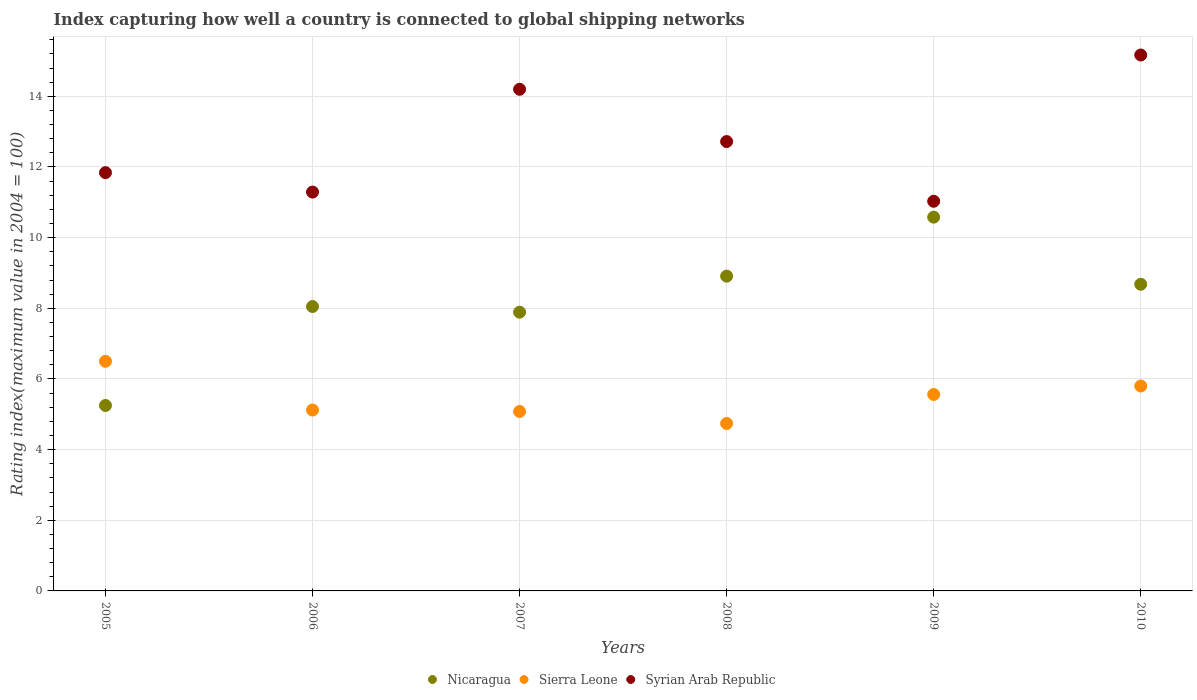What is the rating index in Nicaragua in 2006?
Offer a terse response. 8.05. Across all years, what is the minimum rating index in Sierra Leone?
Offer a terse response. 4.74. In which year was the rating index in Nicaragua maximum?
Your answer should be compact. 2009. What is the total rating index in Nicaragua in the graph?
Make the answer very short. 49.36. What is the difference between the rating index in Nicaragua in 2005 and that in 2009?
Offer a very short reply. -5.33. What is the difference between the rating index in Sierra Leone in 2005 and the rating index in Nicaragua in 2008?
Provide a succinct answer. -2.41. What is the average rating index in Syrian Arab Republic per year?
Your response must be concise. 12.71. In the year 2005, what is the difference between the rating index in Syrian Arab Republic and rating index in Sierra Leone?
Your answer should be compact. 5.34. In how many years, is the rating index in Sierra Leone greater than 9.2?
Give a very brief answer. 0. What is the ratio of the rating index in Nicaragua in 2007 to that in 2009?
Your answer should be very brief. 0.75. Is the difference between the rating index in Syrian Arab Republic in 2007 and 2009 greater than the difference between the rating index in Sierra Leone in 2007 and 2009?
Give a very brief answer. Yes. What is the difference between the highest and the second highest rating index in Nicaragua?
Keep it short and to the point. 1.67. What is the difference between the highest and the lowest rating index in Syrian Arab Republic?
Give a very brief answer. 4.14. In how many years, is the rating index in Nicaragua greater than the average rating index in Nicaragua taken over all years?
Give a very brief answer. 3. Is the sum of the rating index in Nicaragua in 2006 and 2007 greater than the maximum rating index in Sierra Leone across all years?
Provide a short and direct response. Yes. Does the rating index in Nicaragua monotonically increase over the years?
Provide a short and direct response. No. Is the rating index in Nicaragua strictly less than the rating index in Sierra Leone over the years?
Provide a succinct answer. No. How many dotlines are there?
Ensure brevity in your answer.  3. What is the difference between two consecutive major ticks on the Y-axis?
Offer a very short reply. 2. Does the graph contain any zero values?
Make the answer very short. No. Does the graph contain grids?
Your answer should be very brief. Yes. Where does the legend appear in the graph?
Make the answer very short. Bottom center. How many legend labels are there?
Provide a short and direct response. 3. How are the legend labels stacked?
Your response must be concise. Horizontal. What is the title of the graph?
Your answer should be compact. Index capturing how well a country is connected to global shipping networks. Does "Solomon Islands" appear as one of the legend labels in the graph?
Provide a short and direct response. No. What is the label or title of the X-axis?
Make the answer very short. Years. What is the label or title of the Y-axis?
Provide a succinct answer. Rating index(maximum value in 2004 = 100). What is the Rating index(maximum value in 2004 = 100) in Nicaragua in 2005?
Your answer should be compact. 5.25. What is the Rating index(maximum value in 2004 = 100) in Syrian Arab Republic in 2005?
Offer a terse response. 11.84. What is the Rating index(maximum value in 2004 = 100) of Nicaragua in 2006?
Give a very brief answer. 8.05. What is the Rating index(maximum value in 2004 = 100) of Sierra Leone in 2006?
Make the answer very short. 5.12. What is the Rating index(maximum value in 2004 = 100) in Syrian Arab Republic in 2006?
Make the answer very short. 11.29. What is the Rating index(maximum value in 2004 = 100) in Nicaragua in 2007?
Your response must be concise. 7.89. What is the Rating index(maximum value in 2004 = 100) in Sierra Leone in 2007?
Ensure brevity in your answer.  5.08. What is the Rating index(maximum value in 2004 = 100) in Syrian Arab Republic in 2007?
Make the answer very short. 14.2. What is the Rating index(maximum value in 2004 = 100) of Nicaragua in 2008?
Provide a succinct answer. 8.91. What is the Rating index(maximum value in 2004 = 100) of Sierra Leone in 2008?
Give a very brief answer. 4.74. What is the Rating index(maximum value in 2004 = 100) of Syrian Arab Republic in 2008?
Keep it short and to the point. 12.72. What is the Rating index(maximum value in 2004 = 100) of Nicaragua in 2009?
Give a very brief answer. 10.58. What is the Rating index(maximum value in 2004 = 100) in Sierra Leone in 2009?
Give a very brief answer. 5.56. What is the Rating index(maximum value in 2004 = 100) of Syrian Arab Republic in 2009?
Give a very brief answer. 11.03. What is the Rating index(maximum value in 2004 = 100) in Nicaragua in 2010?
Provide a short and direct response. 8.68. What is the Rating index(maximum value in 2004 = 100) in Sierra Leone in 2010?
Offer a very short reply. 5.8. What is the Rating index(maximum value in 2004 = 100) of Syrian Arab Republic in 2010?
Your answer should be compact. 15.17. Across all years, what is the maximum Rating index(maximum value in 2004 = 100) of Nicaragua?
Provide a succinct answer. 10.58. Across all years, what is the maximum Rating index(maximum value in 2004 = 100) in Sierra Leone?
Make the answer very short. 6.5. Across all years, what is the maximum Rating index(maximum value in 2004 = 100) in Syrian Arab Republic?
Your response must be concise. 15.17. Across all years, what is the minimum Rating index(maximum value in 2004 = 100) in Nicaragua?
Provide a short and direct response. 5.25. Across all years, what is the minimum Rating index(maximum value in 2004 = 100) in Sierra Leone?
Your answer should be compact. 4.74. Across all years, what is the minimum Rating index(maximum value in 2004 = 100) of Syrian Arab Republic?
Provide a short and direct response. 11.03. What is the total Rating index(maximum value in 2004 = 100) in Nicaragua in the graph?
Make the answer very short. 49.36. What is the total Rating index(maximum value in 2004 = 100) in Sierra Leone in the graph?
Offer a very short reply. 32.8. What is the total Rating index(maximum value in 2004 = 100) of Syrian Arab Republic in the graph?
Offer a very short reply. 76.25. What is the difference between the Rating index(maximum value in 2004 = 100) in Nicaragua in 2005 and that in 2006?
Ensure brevity in your answer.  -2.8. What is the difference between the Rating index(maximum value in 2004 = 100) of Sierra Leone in 2005 and that in 2006?
Provide a short and direct response. 1.38. What is the difference between the Rating index(maximum value in 2004 = 100) in Syrian Arab Republic in 2005 and that in 2006?
Give a very brief answer. 0.55. What is the difference between the Rating index(maximum value in 2004 = 100) in Nicaragua in 2005 and that in 2007?
Your answer should be compact. -2.64. What is the difference between the Rating index(maximum value in 2004 = 100) in Sierra Leone in 2005 and that in 2007?
Your answer should be compact. 1.42. What is the difference between the Rating index(maximum value in 2004 = 100) of Syrian Arab Republic in 2005 and that in 2007?
Make the answer very short. -2.36. What is the difference between the Rating index(maximum value in 2004 = 100) of Nicaragua in 2005 and that in 2008?
Your answer should be very brief. -3.66. What is the difference between the Rating index(maximum value in 2004 = 100) in Sierra Leone in 2005 and that in 2008?
Offer a terse response. 1.76. What is the difference between the Rating index(maximum value in 2004 = 100) of Syrian Arab Republic in 2005 and that in 2008?
Your response must be concise. -0.88. What is the difference between the Rating index(maximum value in 2004 = 100) in Nicaragua in 2005 and that in 2009?
Offer a terse response. -5.33. What is the difference between the Rating index(maximum value in 2004 = 100) in Sierra Leone in 2005 and that in 2009?
Your answer should be compact. 0.94. What is the difference between the Rating index(maximum value in 2004 = 100) in Syrian Arab Republic in 2005 and that in 2009?
Ensure brevity in your answer.  0.81. What is the difference between the Rating index(maximum value in 2004 = 100) of Nicaragua in 2005 and that in 2010?
Your answer should be very brief. -3.43. What is the difference between the Rating index(maximum value in 2004 = 100) in Sierra Leone in 2005 and that in 2010?
Offer a very short reply. 0.7. What is the difference between the Rating index(maximum value in 2004 = 100) of Syrian Arab Republic in 2005 and that in 2010?
Your answer should be compact. -3.33. What is the difference between the Rating index(maximum value in 2004 = 100) of Nicaragua in 2006 and that in 2007?
Provide a short and direct response. 0.16. What is the difference between the Rating index(maximum value in 2004 = 100) of Sierra Leone in 2006 and that in 2007?
Provide a succinct answer. 0.04. What is the difference between the Rating index(maximum value in 2004 = 100) of Syrian Arab Republic in 2006 and that in 2007?
Ensure brevity in your answer.  -2.91. What is the difference between the Rating index(maximum value in 2004 = 100) in Nicaragua in 2006 and that in 2008?
Make the answer very short. -0.86. What is the difference between the Rating index(maximum value in 2004 = 100) in Sierra Leone in 2006 and that in 2008?
Give a very brief answer. 0.38. What is the difference between the Rating index(maximum value in 2004 = 100) in Syrian Arab Republic in 2006 and that in 2008?
Your answer should be compact. -1.43. What is the difference between the Rating index(maximum value in 2004 = 100) of Nicaragua in 2006 and that in 2009?
Give a very brief answer. -2.53. What is the difference between the Rating index(maximum value in 2004 = 100) in Sierra Leone in 2006 and that in 2009?
Keep it short and to the point. -0.44. What is the difference between the Rating index(maximum value in 2004 = 100) in Syrian Arab Republic in 2006 and that in 2009?
Offer a terse response. 0.26. What is the difference between the Rating index(maximum value in 2004 = 100) of Nicaragua in 2006 and that in 2010?
Your answer should be very brief. -0.63. What is the difference between the Rating index(maximum value in 2004 = 100) of Sierra Leone in 2006 and that in 2010?
Your response must be concise. -0.68. What is the difference between the Rating index(maximum value in 2004 = 100) in Syrian Arab Republic in 2006 and that in 2010?
Make the answer very short. -3.88. What is the difference between the Rating index(maximum value in 2004 = 100) of Nicaragua in 2007 and that in 2008?
Keep it short and to the point. -1.02. What is the difference between the Rating index(maximum value in 2004 = 100) of Sierra Leone in 2007 and that in 2008?
Ensure brevity in your answer.  0.34. What is the difference between the Rating index(maximum value in 2004 = 100) of Syrian Arab Republic in 2007 and that in 2008?
Provide a short and direct response. 1.48. What is the difference between the Rating index(maximum value in 2004 = 100) in Nicaragua in 2007 and that in 2009?
Provide a short and direct response. -2.69. What is the difference between the Rating index(maximum value in 2004 = 100) in Sierra Leone in 2007 and that in 2009?
Make the answer very short. -0.48. What is the difference between the Rating index(maximum value in 2004 = 100) in Syrian Arab Republic in 2007 and that in 2009?
Provide a short and direct response. 3.17. What is the difference between the Rating index(maximum value in 2004 = 100) of Nicaragua in 2007 and that in 2010?
Provide a short and direct response. -0.79. What is the difference between the Rating index(maximum value in 2004 = 100) in Sierra Leone in 2007 and that in 2010?
Offer a terse response. -0.72. What is the difference between the Rating index(maximum value in 2004 = 100) in Syrian Arab Republic in 2007 and that in 2010?
Make the answer very short. -0.97. What is the difference between the Rating index(maximum value in 2004 = 100) in Nicaragua in 2008 and that in 2009?
Your answer should be very brief. -1.67. What is the difference between the Rating index(maximum value in 2004 = 100) in Sierra Leone in 2008 and that in 2009?
Make the answer very short. -0.82. What is the difference between the Rating index(maximum value in 2004 = 100) of Syrian Arab Republic in 2008 and that in 2009?
Make the answer very short. 1.69. What is the difference between the Rating index(maximum value in 2004 = 100) in Nicaragua in 2008 and that in 2010?
Ensure brevity in your answer.  0.23. What is the difference between the Rating index(maximum value in 2004 = 100) in Sierra Leone in 2008 and that in 2010?
Your answer should be very brief. -1.06. What is the difference between the Rating index(maximum value in 2004 = 100) of Syrian Arab Republic in 2008 and that in 2010?
Your response must be concise. -2.45. What is the difference between the Rating index(maximum value in 2004 = 100) in Nicaragua in 2009 and that in 2010?
Ensure brevity in your answer.  1.9. What is the difference between the Rating index(maximum value in 2004 = 100) in Sierra Leone in 2009 and that in 2010?
Provide a succinct answer. -0.24. What is the difference between the Rating index(maximum value in 2004 = 100) in Syrian Arab Republic in 2009 and that in 2010?
Offer a very short reply. -4.14. What is the difference between the Rating index(maximum value in 2004 = 100) of Nicaragua in 2005 and the Rating index(maximum value in 2004 = 100) of Sierra Leone in 2006?
Make the answer very short. 0.13. What is the difference between the Rating index(maximum value in 2004 = 100) of Nicaragua in 2005 and the Rating index(maximum value in 2004 = 100) of Syrian Arab Republic in 2006?
Keep it short and to the point. -6.04. What is the difference between the Rating index(maximum value in 2004 = 100) of Sierra Leone in 2005 and the Rating index(maximum value in 2004 = 100) of Syrian Arab Republic in 2006?
Your answer should be very brief. -4.79. What is the difference between the Rating index(maximum value in 2004 = 100) of Nicaragua in 2005 and the Rating index(maximum value in 2004 = 100) of Sierra Leone in 2007?
Offer a terse response. 0.17. What is the difference between the Rating index(maximum value in 2004 = 100) of Nicaragua in 2005 and the Rating index(maximum value in 2004 = 100) of Syrian Arab Republic in 2007?
Provide a succinct answer. -8.95. What is the difference between the Rating index(maximum value in 2004 = 100) of Sierra Leone in 2005 and the Rating index(maximum value in 2004 = 100) of Syrian Arab Republic in 2007?
Give a very brief answer. -7.7. What is the difference between the Rating index(maximum value in 2004 = 100) in Nicaragua in 2005 and the Rating index(maximum value in 2004 = 100) in Sierra Leone in 2008?
Your answer should be very brief. 0.51. What is the difference between the Rating index(maximum value in 2004 = 100) of Nicaragua in 2005 and the Rating index(maximum value in 2004 = 100) of Syrian Arab Republic in 2008?
Ensure brevity in your answer.  -7.47. What is the difference between the Rating index(maximum value in 2004 = 100) of Sierra Leone in 2005 and the Rating index(maximum value in 2004 = 100) of Syrian Arab Republic in 2008?
Provide a succinct answer. -6.22. What is the difference between the Rating index(maximum value in 2004 = 100) of Nicaragua in 2005 and the Rating index(maximum value in 2004 = 100) of Sierra Leone in 2009?
Give a very brief answer. -0.31. What is the difference between the Rating index(maximum value in 2004 = 100) in Nicaragua in 2005 and the Rating index(maximum value in 2004 = 100) in Syrian Arab Republic in 2009?
Keep it short and to the point. -5.78. What is the difference between the Rating index(maximum value in 2004 = 100) of Sierra Leone in 2005 and the Rating index(maximum value in 2004 = 100) of Syrian Arab Republic in 2009?
Your answer should be compact. -4.53. What is the difference between the Rating index(maximum value in 2004 = 100) in Nicaragua in 2005 and the Rating index(maximum value in 2004 = 100) in Sierra Leone in 2010?
Provide a succinct answer. -0.55. What is the difference between the Rating index(maximum value in 2004 = 100) in Nicaragua in 2005 and the Rating index(maximum value in 2004 = 100) in Syrian Arab Republic in 2010?
Make the answer very short. -9.92. What is the difference between the Rating index(maximum value in 2004 = 100) of Sierra Leone in 2005 and the Rating index(maximum value in 2004 = 100) of Syrian Arab Republic in 2010?
Ensure brevity in your answer.  -8.67. What is the difference between the Rating index(maximum value in 2004 = 100) of Nicaragua in 2006 and the Rating index(maximum value in 2004 = 100) of Sierra Leone in 2007?
Give a very brief answer. 2.97. What is the difference between the Rating index(maximum value in 2004 = 100) in Nicaragua in 2006 and the Rating index(maximum value in 2004 = 100) in Syrian Arab Republic in 2007?
Your answer should be very brief. -6.15. What is the difference between the Rating index(maximum value in 2004 = 100) of Sierra Leone in 2006 and the Rating index(maximum value in 2004 = 100) of Syrian Arab Republic in 2007?
Offer a terse response. -9.08. What is the difference between the Rating index(maximum value in 2004 = 100) in Nicaragua in 2006 and the Rating index(maximum value in 2004 = 100) in Sierra Leone in 2008?
Ensure brevity in your answer.  3.31. What is the difference between the Rating index(maximum value in 2004 = 100) in Nicaragua in 2006 and the Rating index(maximum value in 2004 = 100) in Syrian Arab Republic in 2008?
Ensure brevity in your answer.  -4.67. What is the difference between the Rating index(maximum value in 2004 = 100) of Sierra Leone in 2006 and the Rating index(maximum value in 2004 = 100) of Syrian Arab Republic in 2008?
Ensure brevity in your answer.  -7.6. What is the difference between the Rating index(maximum value in 2004 = 100) in Nicaragua in 2006 and the Rating index(maximum value in 2004 = 100) in Sierra Leone in 2009?
Provide a short and direct response. 2.49. What is the difference between the Rating index(maximum value in 2004 = 100) of Nicaragua in 2006 and the Rating index(maximum value in 2004 = 100) of Syrian Arab Republic in 2009?
Provide a succinct answer. -2.98. What is the difference between the Rating index(maximum value in 2004 = 100) of Sierra Leone in 2006 and the Rating index(maximum value in 2004 = 100) of Syrian Arab Republic in 2009?
Give a very brief answer. -5.91. What is the difference between the Rating index(maximum value in 2004 = 100) in Nicaragua in 2006 and the Rating index(maximum value in 2004 = 100) in Sierra Leone in 2010?
Ensure brevity in your answer.  2.25. What is the difference between the Rating index(maximum value in 2004 = 100) in Nicaragua in 2006 and the Rating index(maximum value in 2004 = 100) in Syrian Arab Republic in 2010?
Provide a short and direct response. -7.12. What is the difference between the Rating index(maximum value in 2004 = 100) in Sierra Leone in 2006 and the Rating index(maximum value in 2004 = 100) in Syrian Arab Republic in 2010?
Ensure brevity in your answer.  -10.05. What is the difference between the Rating index(maximum value in 2004 = 100) of Nicaragua in 2007 and the Rating index(maximum value in 2004 = 100) of Sierra Leone in 2008?
Make the answer very short. 3.15. What is the difference between the Rating index(maximum value in 2004 = 100) of Nicaragua in 2007 and the Rating index(maximum value in 2004 = 100) of Syrian Arab Republic in 2008?
Make the answer very short. -4.83. What is the difference between the Rating index(maximum value in 2004 = 100) of Sierra Leone in 2007 and the Rating index(maximum value in 2004 = 100) of Syrian Arab Republic in 2008?
Provide a short and direct response. -7.64. What is the difference between the Rating index(maximum value in 2004 = 100) in Nicaragua in 2007 and the Rating index(maximum value in 2004 = 100) in Sierra Leone in 2009?
Provide a short and direct response. 2.33. What is the difference between the Rating index(maximum value in 2004 = 100) in Nicaragua in 2007 and the Rating index(maximum value in 2004 = 100) in Syrian Arab Republic in 2009?
Your answer should be very brief. -3.14. What is the difference between the Rating index(maximum value in 2004 = 100) in Sierra Leone in 2007 and the Rating index(maximum value in 2004 = 100) in Syrian Arab Republic in 2009?
Offer a terse response. -5.95. What is the difference between the Rating index(maximum value in 2004 = 100) of Nicaragua in 2007 and the Rating index(maximum value in 2004 = 100) of Sierra Leone in 2010?
Offer a very short reply. 2.09. What is the difference between the Rating index(maximum value in 2004 = 100) of Nicaragua in 2007 and the Rating index(maximum value in 2004 = 100) of Syrian Arab Republic in 2010?
Offer a terse response. -7.28. What is the difference between the Rating index(maximum value in 2004 = 100) of Sierra Leone in 2007 and the Rating index(maximum value in 2004 = 100) of Syrian Arab Republic in 2010?
Offer a very short reply. -10.09. What is the difference between the Rating index(maximum value in 2004 = 100) in Nicaragua in 2008 and the Rating index(maximum value in 2004 = 100) in Sierra Leone in 2009?
Offer a terse response. 3.35. What is the difference between the Rating index(maximum value in 2004 = 100) in Nicaragua in 2008 and the Rating index(maximum value in 2004 = 100) in Syrian Arab Republic in 2009?
Your answer should be very brief. -2.12. What is the difference between the Rating index(maximum value in 2004 = 100) of Sierra Leone in 2008 and the Rating index(maximum value in 2004 = 100) of Syrian Arab Republic in 2009?
Your response must be concise. -6.29. What is the difference between the Rating index(maximum value in 2004 = 100) in Nicaragua in 2008 and the Rating index(maximum value in 2004 = 100) in Sierra Leone in 2010?
Make the answer very short. 3.11. What is the difference between the Rating index(maximum value in 2004 = 100) of Nicaragua in 2008 and the Rating index(maximum value in 2004 = 100) of Syrian Arab Republic in 2010?
Offer a terse response. -6.26. What is the difference between the Rating index(maximum value in 2004 = 100) in Sierra Leone in 2008 and the Rating index(maximum value in 2004 = 100) in Syrian Arab Republic in 2010?
Your answer should be very brief. -10.43. What is the difference between the Rating index(maximum value in 2004 = 100) of Nicaragua in 2009 and the Rating index(maximum value in 2004 = 100) of Sierra Leone in 2010?
Provide a short and direct response. 4.78. What is the difference between the Rating index(maximum value in 2004 = 100) in Nicaragua in 2009 and the Rating index(maximum value in 2004 = 100) in Syrian Arab Republic in 2010?
Ensure brevity in your answer.  -4.59. What is the difference between the Rating index(maximum value in 2004 = 100) of Sierra Leone in 2009 and the Rating index(maximum value in 2004 = 100) of Syrian Arab Republic in 2010?
Offer a very short reply. -9.61. What is the average Rating index(maximum value in 2004 = 100) in Nicaragua per year?
Make the answer very short. 8.23. What is the average Rating index(maximum value in 2004 = 100) of Sierra Leone per year?
Your answer should be compact. 5.47. What is the average Rating index(maximum value in 2004 = 100) in Syrian Arab Republic per year?
Make the answer very short. 12.71. In the year 2005, what is the difference between the Rating index(maximum value in 2004 = 100) of Nicaragua and Rating index(maximum value in 2004 = 100) of Sierra Leone?
Keep it short and to the point. -1.25. In the year 2005, what is the difference between the Rating index(maximum value in 2004 = 100) in Nicaragua and Rating index(maximum value in 2004 = 100) in Syrian Arab Republic?
Ensure brevity in your answer.  -6.59. In the year 2005, what is the difference between the Rating index(maximum value in 2004 = 100) in Sierra Leone and Rating index(maximum value in 2004 = 100) in Syrian Arab Republic?
Ensure brevity in your answer.  -5.34. In the year 2006, what is the difference between the Rating index(maximum value in 2004 = 100) of Nicaragua and Rating index(maximum value in 2004 = 100) of Sierra Leone?
Your answer should be compact. 2.93. In the year 2006, what is the difference between the Rating index(maximum value in 2004 = 100) of Nicaragua and Rating index(maximum value in 2004 = 100) of Syrian Arab Republic?
Your answer should be very brief. -3.24. In the year 2006, what is the difference between the Rating index(maximum value in 2004 = 100) in Sierra Leone and Rating index(maximum value in 2004 = 100) in Syrian Arab Republic?
Your answer should be very brief. -6.17. In the year 2007, what is the difference between the Rating index(maximum value in 2004 = 100) in Nicaragua and Rating index(maximum value in 2004 = 100) in Sierra Leone?
Provide a succinct answer. 2.81. In the year 2007, what is the difference between the Rating index(maximum value in 2004 = 100) in Nicaragua and Rating index(maximum value in 2004 = 100) in Syrian Arab Republic?
Your response must be concise. -6.31. In the year 2007, what is the difference between the Rating index(maximum value in 2004 = 100) in Sierra Leone and Rating index(maximum value in 2004 = 100) in Syrian Arab Republic?
Your answer should be compact. -9.12. In the year 2008, what is the difference between the Rating index(maximum value in 2004 = 100) in Nicaragua and Rating index(maximum value in 2004 = 100) in Sierra Leone?
Provide a short and direct response. 4.17. In the year 2008, what is the difference between the Rating index(maximum value in 2004 = 100) of Nicaragua and Rating index(maximum value in 2004 = 100) of Syrian Arab Republic?
Keep it short and to the point. -3.81. In the year 2008, what is the difference between the Rating index(maximum value in 2004 = 100) of Sierra Leone and Rating index(maximum value in 2004 = 100) of Syrian Arab Republic?
Offer a very short reply. -7.98. In the year 2009, what is the difference between the Rating index(maximum value in 2004 = 100) in Nicaragua and Rating index(maximum value in 2004 = 100) in Sierra Leone?
Your answer should be very brief. 5.02. In the year 2009, what is the difference between the Rating index(maximum value in 2004 = 100) in Nicaragua and Rating index(maximum value in 2004 = 100) in Syrian Arab Republic?
Offer a very short reply. -0.45. In the year 2009, what is the difference between the Rating index(maximum value in 2004 = 100) in Sierra Leone and Rating index(maximum value in 2004 = 100) in Syrian Arab Republic?
Your response must be concise. -5.47. In the year 2010, what is the difference between the Rating index(maximum value in 2004 = 100) of Nicaragua and Rating index(maximum value in 2004 = 100) of Sierra Leone?
Make the answer very short. 2.88. In the year 2010, what is the difference between the Rating index(maximum value in 2004 = 100) of Nicaragua and Rating index(maximum value in 2004 = 100) of Syrian Arab Republic?
Keep it short and to the point. -6.49. In the year 2010, what is the difference between the Rating index(maximum value in 2004 = 100) of Sierra Leone and Rating index(maximum value in 2004 = 100) of Syrian Arab Republic?
Your answer should be very brief. -9.37. What is the ratio of the Rating index(maximum value in 2004 = 100) in Nicaragua in 2005 to that in 2006?
Provide a succinct answer. 0.65. What is the ratio of the Rating index(maximum value in 2004 = 100) of Sierra Leone in 2005 to that in 2006?
Ensure brevity in your answer.  1.27. What is the ratio of the Rating index(maximum value in 2004 = 100) of Syrian Arab Republic in 2005 to that in 2006?
Provide a succinct answer. 1.05. What is the ratio of the Rating index(maximum value in 2004 = 100) of Nicaragua in 2005 to that in 2007?
Offer a terse response. 0.67. What is the ratio of the Rating index(maximum value in 2004 = 100) in Sierra Leone in 2005 to that in 2007?
Provide a short and direct response. 1.28. What is the ratio of the Rating index(maximum value in 2004 = 100) of Syrian Arab Republic in 2005 to that in 2007?
Provide a short and direct response. 0.83. What is the ratio of the Rating index(maximum value in 2004 = 100) of Nicaragua in 2005 to that in 2008?
Make the answer very short. 0.59. What is the ratio of the Rating index(maximum value in 2004 = 100) of Sierra Leone in 2005 to that in 2008?
Offer a very short reply. 1.37. What is the ratio of the Rating index(maximum value in 2004 = 100) of Syrian Arab Republic in 2005 to that in 2008?
Offer a terse response. 0.93. What is the ratio of the Rating index(maximum value in 2004 = 100) in Nicaragua in 2005 to that in 2009?
Offer a very short reply. 0.5. What is the ratio of the Rating index(maximum value in 2004 = 100) of Sierra Leone in 2005 to that in 2009?
Offer a terse response. 1.17. What is the ratio of the Rating index(maximum value in 2004 = 100) of Syrian Arab Republic in 2005 to that in 2009?
Your answer should be compact. 1.07. What is the ratio of the Rating index(maximum value in 2004 = 100) in Nicaragua in 2005 to that in 2010?
Give a very brief answer. 0.6. What is the ratio of the Rating index(maximum value in 2004 = 100) of Sierra Leone in 2005 to that in 2010?
Provide a succinct answer. 1.12. What is the ratio of the Rating index(maximum value in 2004 = 100) of Syrian Arab Republic in 2005 to that in 2010?
Offer a very short reply. 0.78. What is the ratio of the Rating index(maximum value in 2004 = 100) in Nicaragua in 2006 to that in 2007?
Give a very brief answer. 1.02. What is the ratio of the Rating index(maximum value in 2004 = 100) of Sierra Leone in 2006 to that in 2007?
Offer a very short reply. 1.01. What is the ratio of the Rating index(maximum value in 2004 = 100) in Syrian Arab Republic in 2006 to that in 2007?
Your answer should be compact. 0.8. What is the ratio of the Rating index(maximum value in 2004 = 100) of Nicaragua in 2006 to that in 2008?
Make the answer very short. 0.9. What is the ratio of the Rating index(maximum value in 2004 = 100) of Sierra Leone in 2006 to that in 2008?
Give a very brief answer. 1.08. What is the ratio of the Rating index(maximum value in 2004 = 100) in Syrian Arab Republic in 2006 to that in 2008?
Give a very brief answer. 0.89. What is the ratio of the Rating index(maximum value in 2004 = 100) in Nicaragua in 2006 to that in 2009?
Make the answer very short. 0.76. What is the ratio of the Rating index(maximum value in 2004 = 100) in Sierra Leone in 2006 to that in 2009?
Give a very brief answer. 0.92. What is the ratio of the Rating index(maximum value in 2004 = 100) of Syrian Arab Republic in 2006 to that in 2009?
Offer a terse response. 1.02. What is the ratio of the Rating index(maximum value in 2004 = 100) of Nicaragua in 2006 to that in 2010?
Give a very brief answer. 0.93. What is the ratio of the Rating index(maximum value in 2004 = 100) in Sierra Leone in 2006 to that in 2010?
Your answer should be compact. 0.88. What is the ratio of the Rating index(maximum value in 2004 = 100) in Syrian Arab Republic in 2006 to that in 2010?
Your answer should be compact. 0.74. What is the ratio of the Rating index(maximum value in 2004 = 100) of Nicaragua in 2007 to that in 2008?
Provide a short and direct response. 0.89. What is the ratio of the Rating index(maximum value in 2004 = 100) of Sierra Leone in 2007 to that in 2008?
Offer a terse response. 1.07. What is the ratio of the Rating index(maximum value in 2004 = 100) of Syrian Arab Republic in 2007 to that in 2008?
Make the answer very short. 1.12. What is the ratio of the Rating index(maximum value in 2004 = 100) of Nicaragua in 2007 to that in 2009?
Ensure brevity in your answer.  0.75. What is the ratio of the Rating index(maximum value in 2004 = 100) in Sierra Leone in 2007 to that in 2009?
Make the answer very short. 0.91. What is the ratio of the Rating index(maximum value in 2004 = 100) in Syrian Arab Republic in 2007 to that in 2009?
Keep it short and to the point. 1.29. What is the ratio of the Rating index(maximum value in 2004 = 100) in Nicaragua in 2007 to that in 2010?
Your answer should be compact. 0.91. What is the ratio of the Rating index(maximum value in 2004 = 100) of Sierra Leone in 2007 to that in 2010?
Offer a very short reply. 0.88. What is the ratio of the Rating index(maximum value in 2004 = 100) of Syrian Arab Republic in 2007 to that in 2010?
Ensure brevity in your answer.  0.94. What is the ratio of the Rating index(maximum value in 2004 = 100) of Nicaragua in 2008 to that in 2009?
Give a very brief answer. 0.84. What is the ratio of the Rating index(maximum value in 2004 = 100) of Sierra Leone in 2008 to that in 2009?
Ensure brevity in your answer.  0.85. What is the ratio of the Rating index(maximum value in 2004 = 100) in Syrian Arab Republic in 2008 to that in 2009?
Provide a succinct answer. 1.15. What is the ratio of the Rating index(maximum value in 2004 = 100) of Nicaragua in 2008 to that in 2010?
Ensure brevity in your answer.  1.03. What is the ratio of the Rating index(maximum value in 2004 = 100) in Sierra Leone in 2008 to that in 2010?
Provide a succinct answer. 0.82. What is the ratio of the Rating index(maximum value in 2004 = 100) of Syrian Arab Republic in 2008 to that in 2010?
Your answer should be very brief. 0.84. What is the ratio of the Rating index(maximum value in 2004 = 100) in Nicaragua in 2009 to that in 2010?
Ensure brevity in your answer.  1.22. What is the ratio of the Rating index(maximum value in 2004 = 100) of Sierra Leone in 2009 to that in 2010?
Make the answer very short. 0.96. What is the ratio of the Rating index(maximum value in 2004 = 100) of Syrian Arab Republic in 2009 to that in 2010?
Ensure brevity in your answer.  0.73. What is the difference between the highest and the second highest Rating index(maximum value in 2004 = 100) in Nicaragua?
Make the answer very short. 1.67. What is the difference between the highest and the second highest Rating index(maximum value in 2004 = 100) in Syrian Arab Republic?
Your answer should be compact. 0.97. What is the difference between the highest and the lowest Rating index(maximum value in 2004 = 100) in Nicaragua?
Make the answer very short. 5.33. What is the difference between the highest and the lowest Rating index(maximum value in 2004 = 100) of Sierra Leone?
Your answer should be very brief. 1.76. What is the difference between the highest and the lowest Rating index(maximum value in 2004 = 100) in Syrian Arab Republic?
Give a very brief answer. 4.14. 